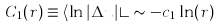<formula> <loc_0><loc_0><loc_500><loc_500>C _ { 1 } ( r ) \equiv \langle \ln | \Delta u | \rangle \sim - c _ { 1 } \ln ( r )</formula> 